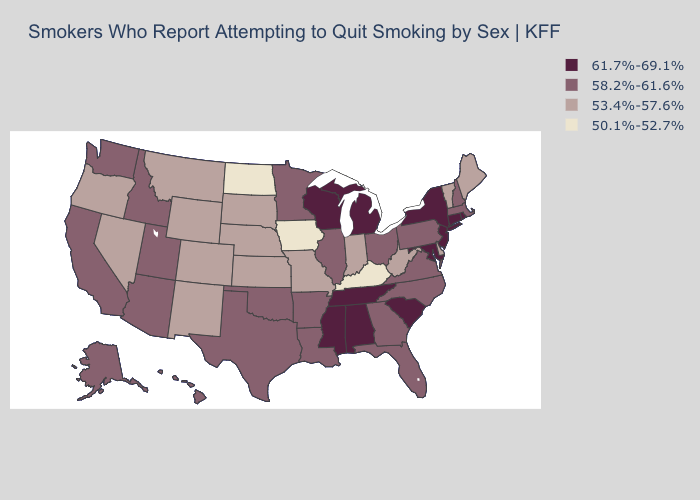What is the value of Hawaii?
Short answer required. 58.2%-61.6%. Does Maine have the same value as Rhode Island?
Concise answer only. No. Does the map have missing data?
Be succinct. No. Among the states that border South Dakota , which have the lowest value?
Give a very brief answer. Iowa, North Dakota. Among the states that border New Hampshire , which have the highest value?
Answer briefly. Massachusetts. Does the map have missing data?
Short answer required. No. What is the value of Rhode Island?
Answer briefly. 61.7%-69.1%. What is the value of Nevada?
Quick response, please. 53.4%-57.6%. What is the value of Montana?
Quick response, please. 53.4%-57.6%. Name the states that have a value in the range 53.4%-57.6%?
Give a very brief answer. Colorado, Delaware, Indiana, Kansas, Maine, Missouri, Montana, Nebraska, Nevada, New Mexico, Oregon, South Dakota, Vermont, West Virginia, Wyoming. What is the value of Florida?
Write a very short answer. 58.2%-61.6%. Does California have a higher value than Illinois?
Keep it brief. No. What is the value of Vermont?
Be succinct. 53.4%-57.6%. Does Kentucky have the lowest value in the South?
Give a very brief answer. Yes. Name the states that have a value in the range 50.1%-52.7%?
Give a very brief answer. Iowa, Kentucky, North Dakota. 